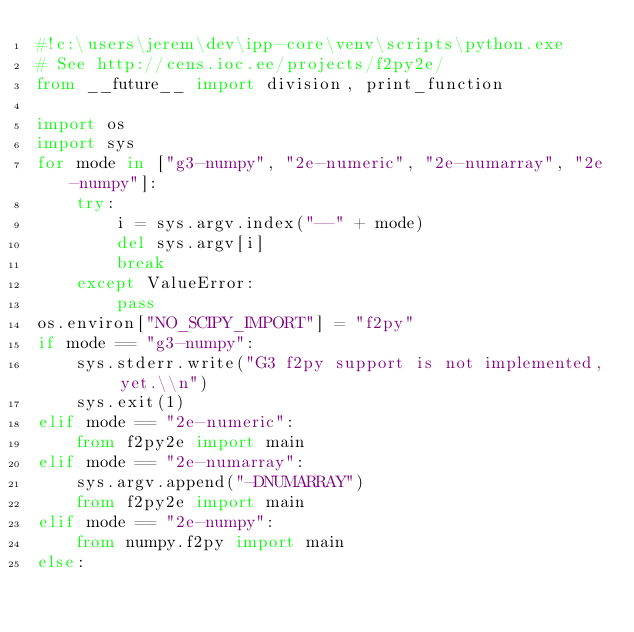<code> <loc_0><loc_0><loc_500><loc_500><_Python_>#!c:\users\jerem\dev\ipp-core\venv\scripts\python.exe
# See http://cens.ioc.ee/projects/f2py2e/
from __future__ import division, print_function

import os
import sys
for mode in ["g3-numpy", "2e-numeric", "2e-numarray", "2e-numpy"]:
    try:
        i = sys.argv.index("--" + mode)
        del sys.argv[i]
        break
    except ValueError:
        pass
os.environ["NO_SCIPY_IMPORT"] = "f2py"
if mode == "g3-numpy":
    sys.stderr.write("G3 f2py support is not implemented, yet.\\n")
    sys.exit(1)
elif mode == "2e-numeric":
    from f2py2e import main
elif mode == "2e-numarray":
    sys.argv.append("-DNUMARRAY")
    from f2py2e import main
elif mode == "2e-numpy":
    from numpy.f2py import main
else:</code> 